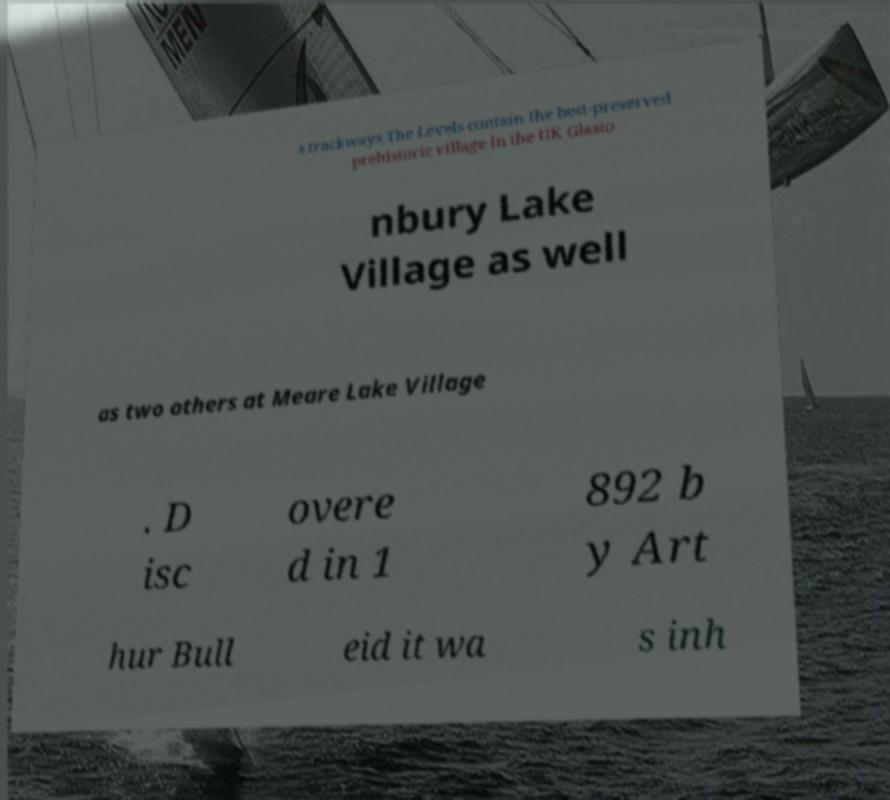For documentation purposes, I need the text within this image transcribed. Could you provide that? s trackways.The Levels contain the best-preserved prehistoric village in the UK Glasto nbury Lake Village as well as two others at Meare Lake Village . D isc overe d in 1 892 b y Art hur Bull eid it wa s inh 